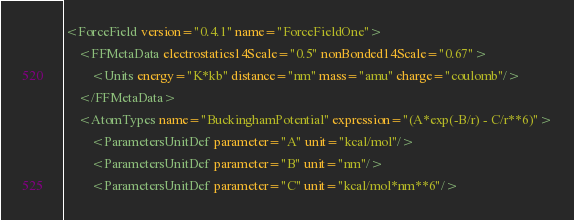Convert code to text. <code><loc_0><loc_0><loc_500><loc_500><_XML_><ForceField version="0.4.1" name="ForceFieldOne">
    <FFMetaData electrostatics14Scale="0.5" nonBonded14Scale="0.67">
        <Units energy="K*kb" distance="nm" mass="amu" charge="coulomb"/>
    </FFMetaData>
    <AtomTypes name="BuckinghamPotential" expression="(A*exp(-B/r) - C/r**6)">
        <ParametersUnitDef parameter="A" unit="kcal/mol"/>
        <ParametersUnitDef parameter="B" unit="nm"/>
        <ParametersUnitDef parameter="C" unit="kcal/mol*nm**6"/></code> 